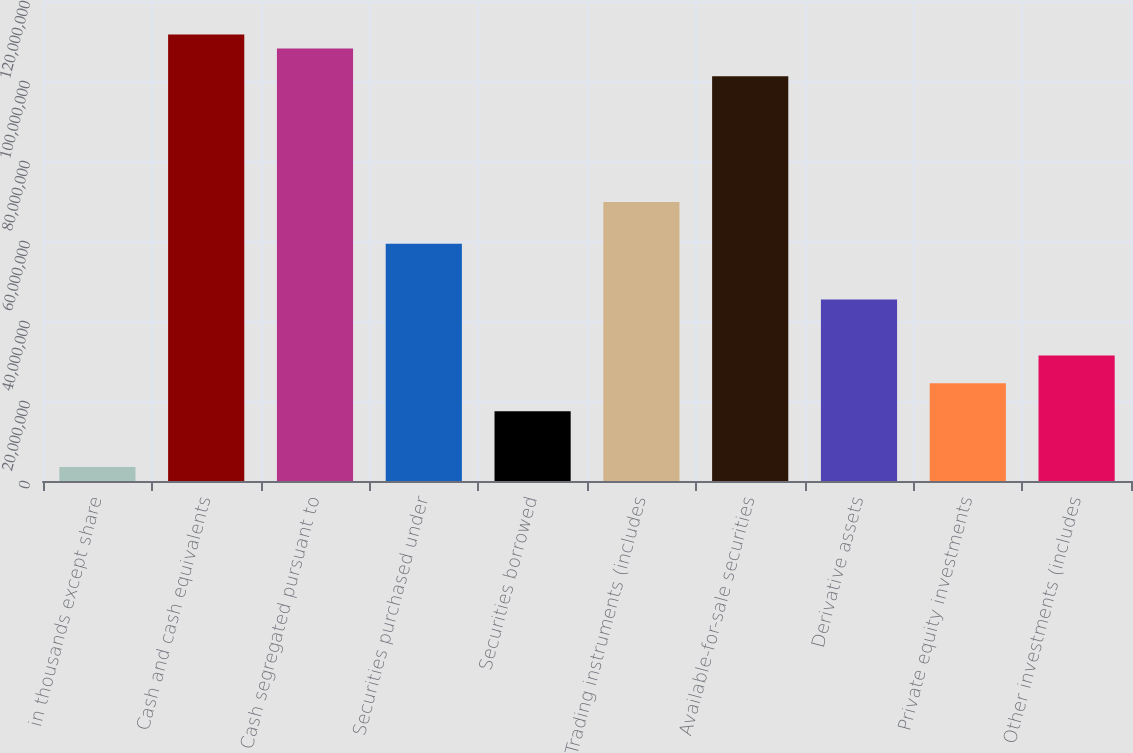Convert chart. <chart><loc_0><loc_0><loc_500><loc_500><bar_chart><fcel>in thousands except share<fcel>Cash and cash equivalents<fcel>Cash segregated pursuant to<fcel>Securities purchased under<fcel>Securities borrowed<fcel>Trading instruments (includes<fcel>Available-for-sale securities<fcel>Derivative assets<fcel>Private equity investments<fcel>Other investments (includes<nl><fcel>3.48973e+06<fcel>1.11624e+08<fcel>1.08135e+08<fcel>5.93008e+07<fcel>1.74425e+07<fcel>6.97654e+07<fcel>1.01159e+08<fcel>4.5348e+07<fcel>2.44189e+07<fcel>3.13953e+07<nl></chart> 